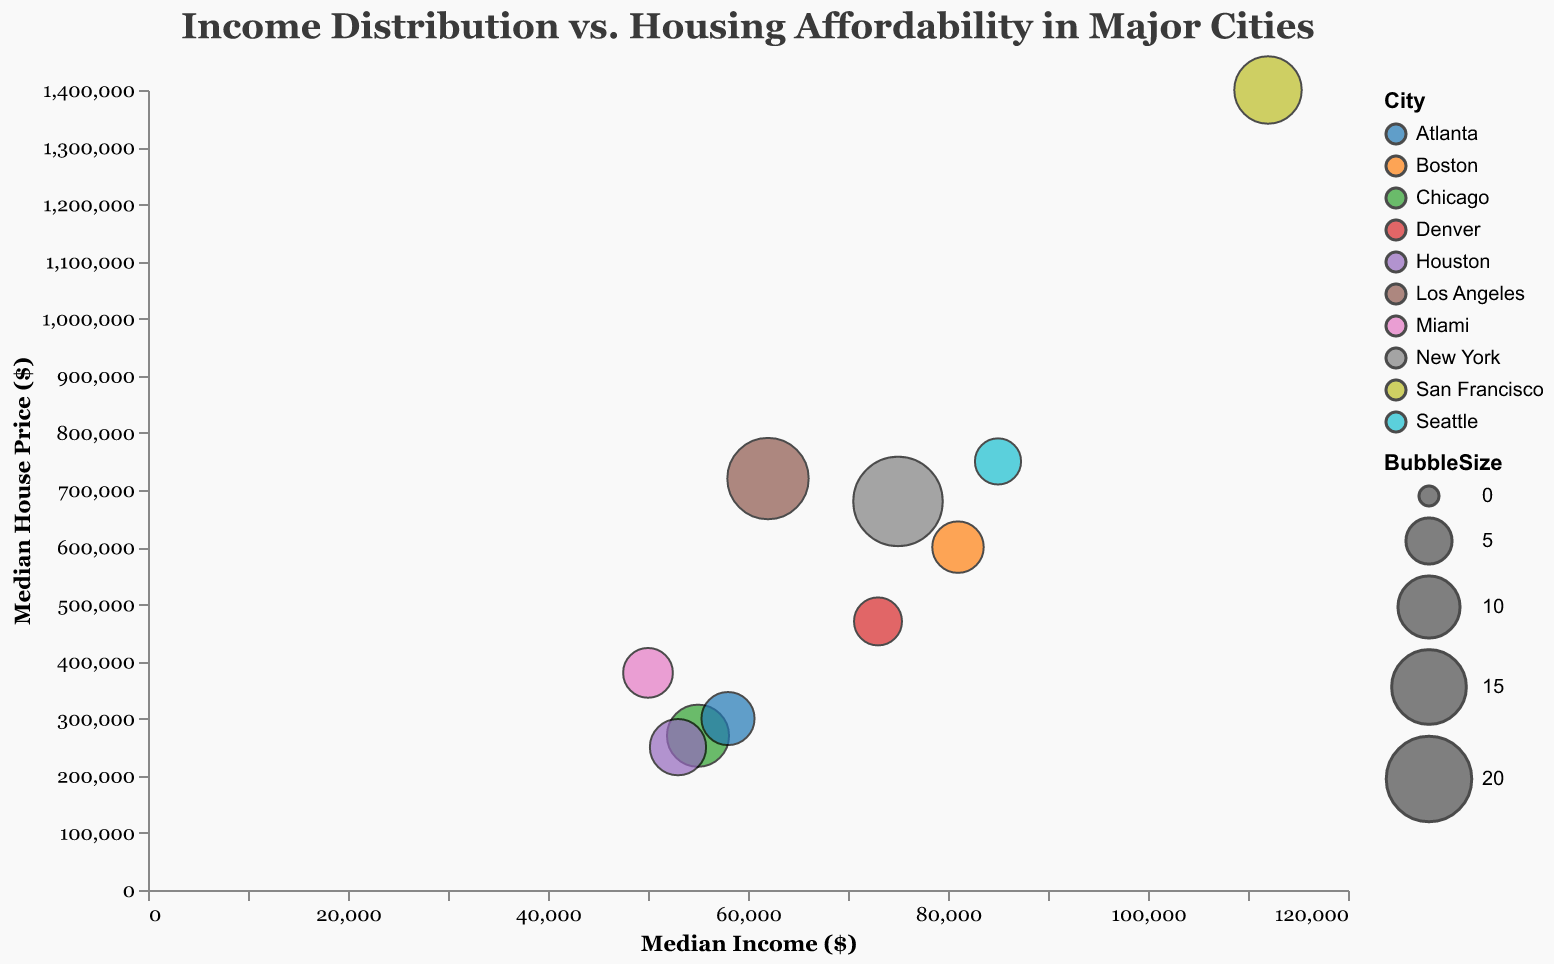What is the title of the bubble chart? The title is located at the top center of the figure and reads "Income Distribution vs. Housing Affordability in Major Cities".
Answer: Income Distribution vs. Housing Affordability in Major Cities What variables are represented on the x-axis and y-axis? The x-axis represents "Median Income ($)" and the y-axis represents "Median House Price ($)". These are indicated by the axis titles.
Answer: Median Income ($), Median House Price ($) Which city has the highest median income, and what is that income? By looking at the x-axis, the city with the farthest right bubble corresponds to San Francisco. The tooltip for this bubble reveals the median income as $112,000.
Answer: San Francisco, $112,000 Which city has the lowest median house price, and what is that price? Looking up from the lowest point on the y-axis, the city represented by the closest bubble at the bottom is Houston. The tooltip shows its median house price as $250,000.
Answer: Houston, $250,000 How does the bubble size relate to the population in this chart? The size of the bubble represents the city's population. Larger bubbles indicate higher populations, and smaller bubbles indicate lower populations.
Answer: Size represents population Which city has the largest bubble, and what is its population? The largest bubble is New York, situated centrally in the chart. The tooltip reveals its population as 8,419,600.
Answer: New York, 8,419,600 Which city has a higher median house price: Los Angeles or Seattle? Looking at the positions on the y-axis, Los Angeles is higher than Seattle. Los Angeles has a median house price of $720,000 compared to Seattle's $750,000.
Answer: Seattle Calculate the difference in median house prices between Boston and Denver. From the y-axis positions, Boston's median house price is $600,000, and Denver's is $470,000. The difference is $600,000 - $470,000 = $130,000.
Answer: $130,000 Between San Francisco and Miami, which city has a more favorable income-to-house price ratio? Explain. San Francisco's median income is $112,000 and median house price is $1,400,000. The ratio is $112,000/$1,400,000 ≈ 0.08. Miami's median income is $50,000 and median house price is $380,000. The ratio is $50,000/$380,000 ≈ 0.13. Miami has a more favorable (higher) ratio.
Answer: Miami Are there any cities with a bubble size smaller than 6? Name them. By examining the smaller bubbles, those with sizes less than 6 are Seattle with a bubble size of 5 and Denver with a bubble size of 5.5.
Answer: Seattle, Denver 